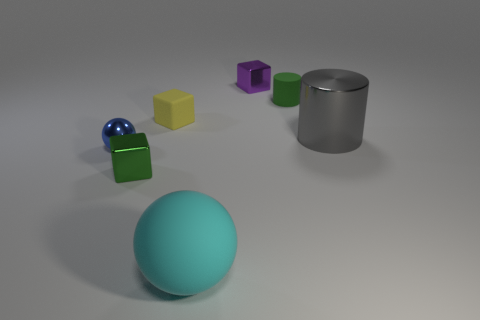There is a yellow thing that is the same shape as the green metallic thing; what is its material?
Keep it short and to the point. Rubber. Is the number of gray things greater than the number of small blocks?
Ensure brevity in your answer.  No. Does the matte cylinder have the same color as the metallic object on the right side of the tiny matte cylinder?
Offer a terse response. No. There is a object that is in front of the small blue object and left of the tiny matte block; what color is it?
Offer a terse response. Green. What number of other objects are there of the same material as the large cyan sphere?
Give a very brief answer. 2. Are there fewer tiny brown metallic balls than tiny yellow things?
Keep it short and to the point. Yes. Are the small blue object and the small cube in front of the blue sphere made of the same material?
Keep it short and to the point. Yes. What shape is the small green thing in front of the big gray metal object?
Your response must be concise. Cube. Are there any other things that are the same color as the big sphere?
Make the answer very short. No. Is the number of green cylinders on the left side of the large cyan matte thing less than the number of big brown spheres?
Your answer should be very brief. No. 